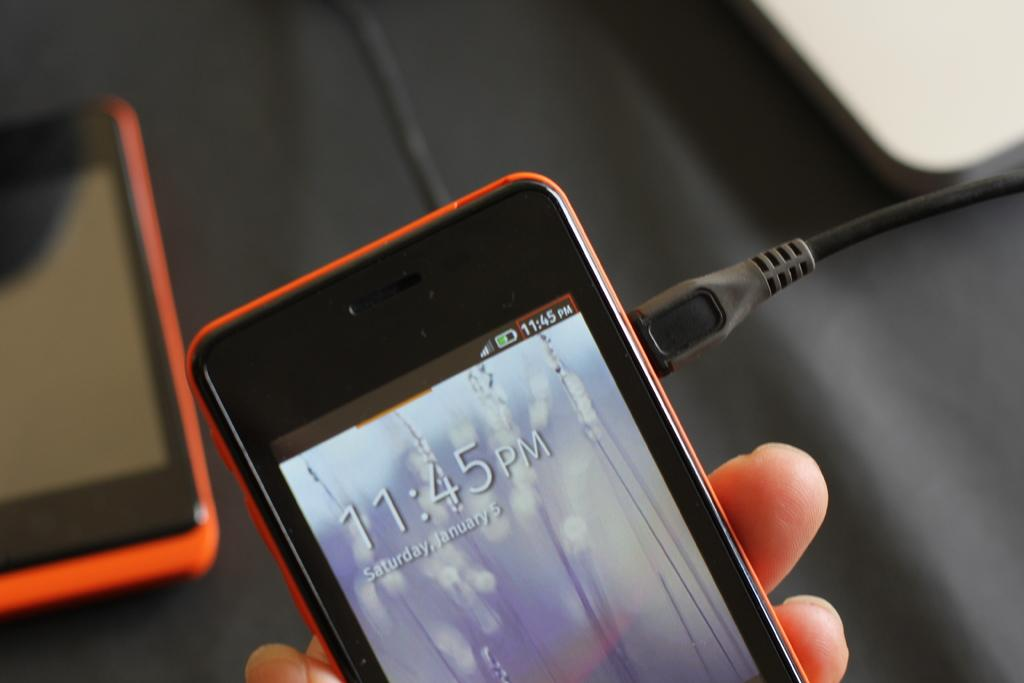<image>
Summarize the visual content of the image. a red cell phone displaying time 11:45 PM 